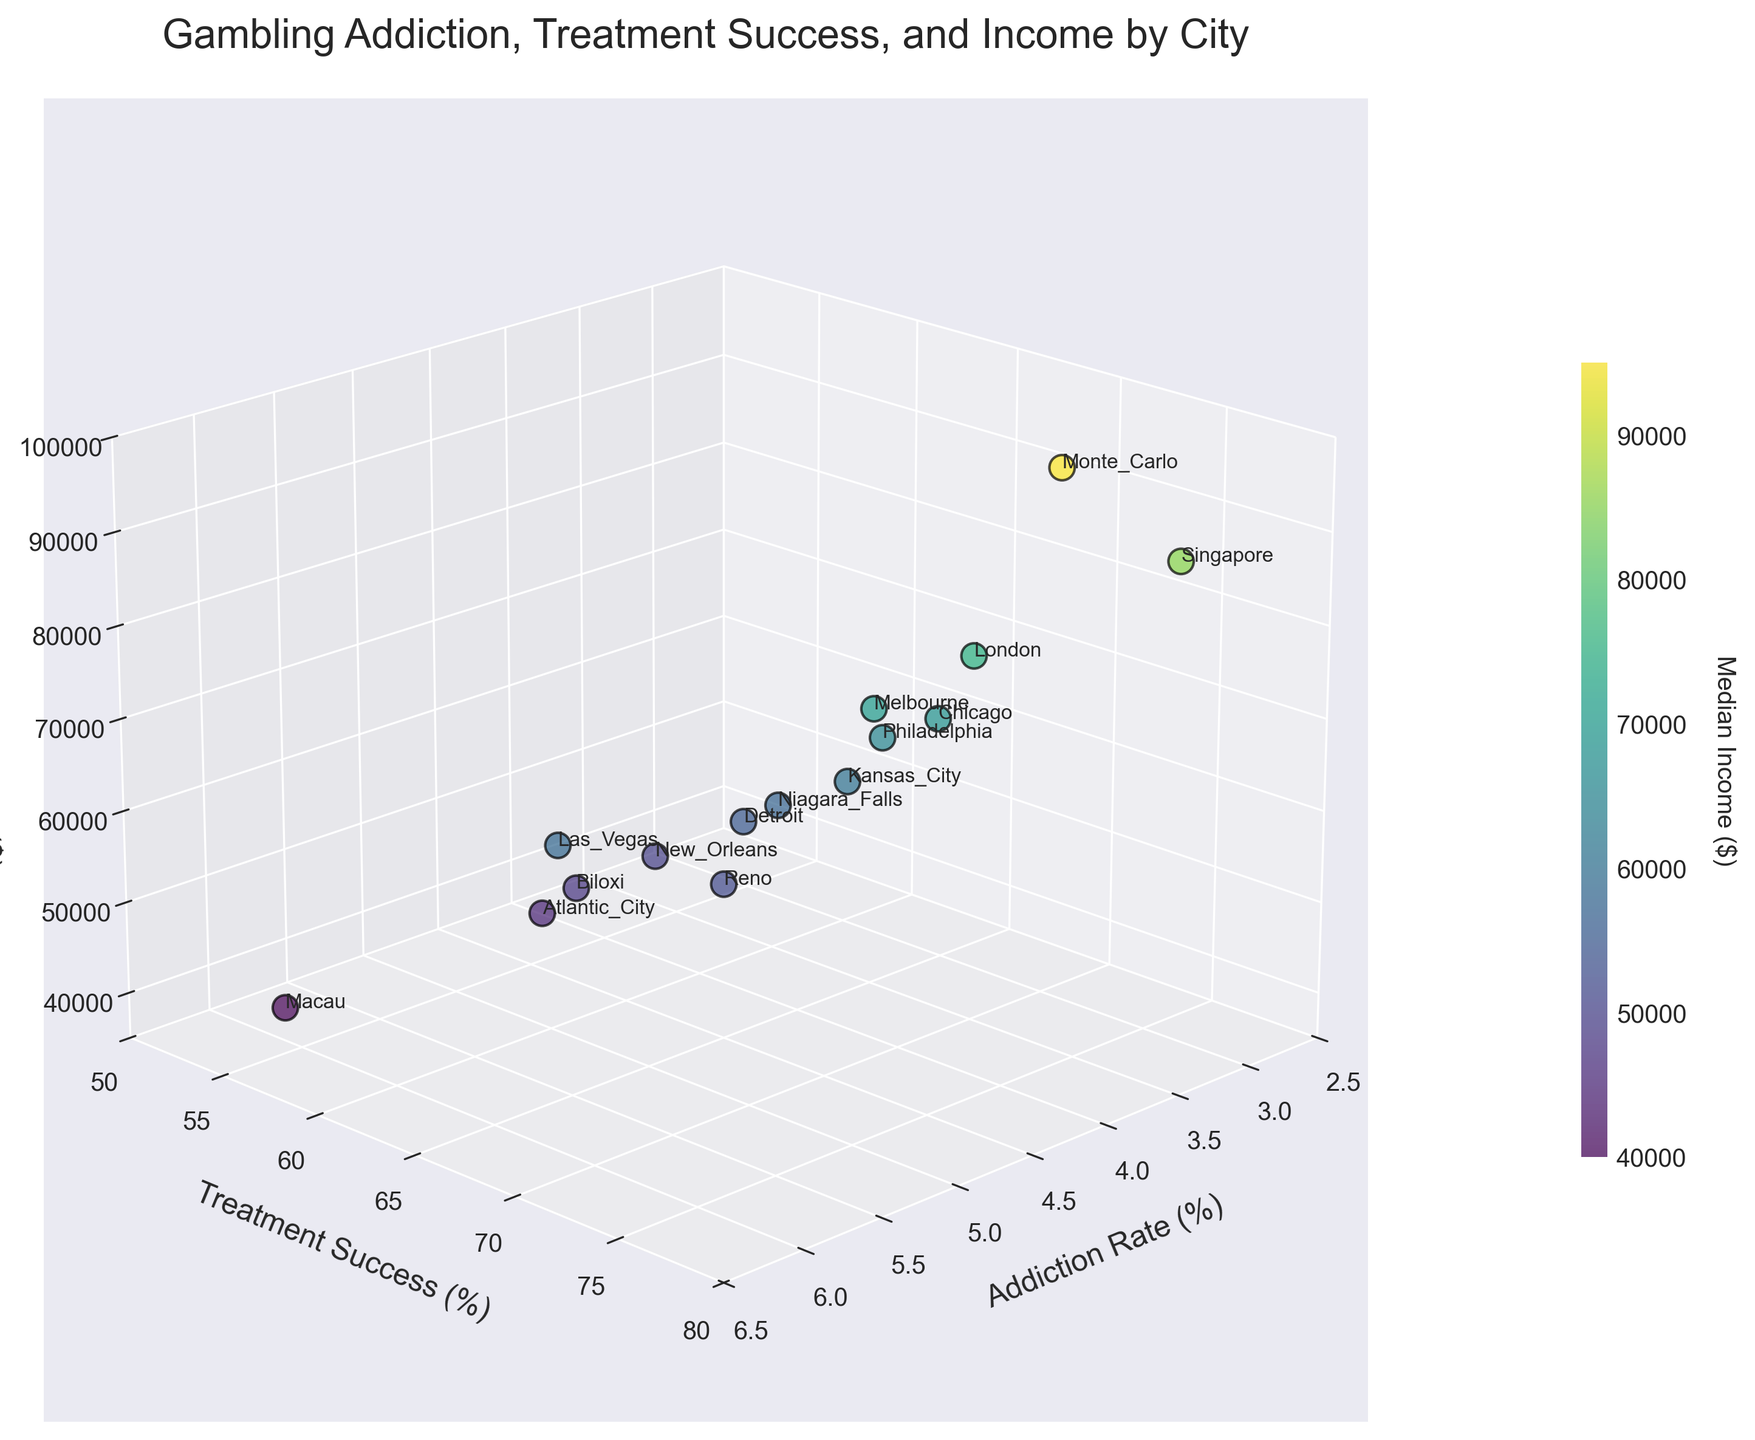What is the title of the figure? The title is displayed at the top of the figure and is usually in a larger font size. It provides a summary of what the figure represents.
Answer: Gambling Addiction, Treatment Success, and Income by City How many cities are represented in the figure? The number of data points in the scatter plot corresponds to the number of cities. Each data point is labeled with a city name. You can count these labels to get the number of cities.
Answer: 15 Which city has the highest addiction rate? To find the city with the highest addiction rate, look for the data point with the highest value on the x-axis (Addiction Rate). The label next to this point will indicate the city.
Answer: Macau What is the median income of Monte Carlo? Locate the data point labeled 'Monte Carlo'. The z-axis (vertical axis) value corresponding to this point represents the median income for Monte Carlo.
Answer: 95,000 Compare the treatment success rates of Las Vegas and Atlantic City. Which city has a higher success rate? Locate the data points labeled 'Las Vegas' and 'Atlantic City'. Compare their y-axis values (Treatment Success). The city with the higher value has a higher treatment success rate.
Answer: Las Vegas What is the average median income of Las Vegas and Reno? Find the median income values (z-axis) for 'Las Vegas' and 'Reno'. Add these two values and divide by 2 to get the average. Median income of Las Vegas is 58,000 and Reno is 52,000. Average is (58,000 + 52,000) / 2 = 55,000
Answer: 55,000 Which city has a higher addiction rate, London or Chicago? Locate the data points labeled 'London' and 'Chicago'. Compare their x-axis values (Addiction Rate). The city with the higher value has a higher addiction rate.
Answer: London What is the difference in median income between Philadelphia and New Orleans? Find the median income values (z-axis) for 'Philadelphia' and 'New Orleans'. Subtract the smaller value from the larger one. Philadelphia's income is 65,000 and New Orleans is 50,000. Difference is 65,000 - 50,000 = 15,000
Answer: 15,000 Which city has the highest treatment success rate? Look for the data point with the highest value on the y-axis (Treatment Success). The label next to this point will indicate the city.
Answer: Singapore Which axis represents the addiction rate? Identify the axis label that reads 'Addiction Rate (%)'. This will be the axis that represents the addiction rate.
Answer: x-axis 